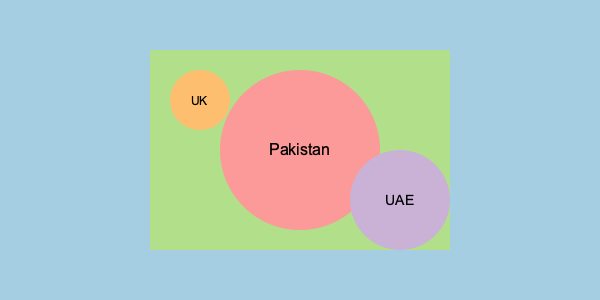Based on the world map representation of Momin Saqib's fan base, which country appears to have the largest concentration of his fans? To determine which country has the largest concentration of Momin Saqib's fans, we need to analyze the map representation:

1. The map shows three distinct circles representing different countries:
   a. A large red circle in the center
   b. A smaller orange circle in the top-left
   c. A medium-sized purple circle in the bottom-right

2. Each circle is labeled with a country name:
   a. The large red circle is labeled "Pakistan"
   b. The small orange circle is labeled "UK"
   c. The medium-sized purple circle is labeled "UAE"

3. The size of each circle corresponds to the relative size of the fan base in that country:
   a. Pakistan's circle is significantly larger than the others
   b. UAE's circle is the second largest
   c. UK's circle is the smallest

4. Given that the largest circle represents Pakistan, we can conclude that Pakistan has the largest concentration of Momin Saqib's fans according to this map representation.

This aligns with the fact that Momin Saqib is a Pakistani content creator and social media personality, making it logical for him to have the largest fan base in his home country.
Answer: Pakistan 